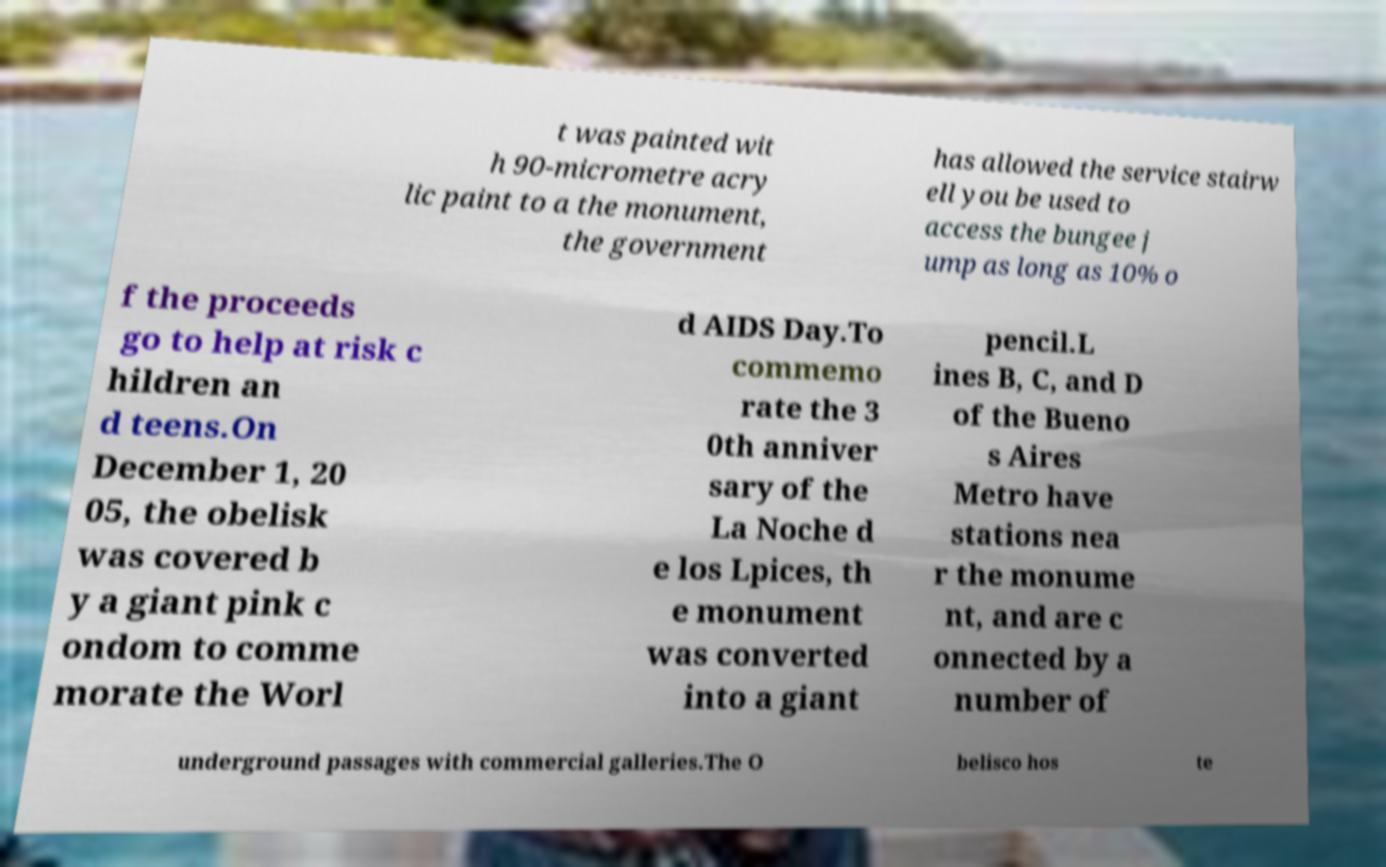Could you assist in decoding the text presented in this image and type it out clearly? t was painted wit h 90-micrometre acry lic paint to a the monument, the government has allowed the service stairw ell you be used to access the bungee j ump as long as 10% o f the proceeds go to help at risk c hildren an d teens.On December 1, 20 05, the obelisk was covered b y a giant pink c ondom to comme morate the Worl d AIDS Day.To commemo rate the 3 0th anniver sary of the La Noche d e los Lpices, th e monument was converted into a giant pencil.L ines B, C, and D of the Bueno s Aires Metro have stations nea r the monume nt, and are c onnected by a number of underground passages with commercial galleries.The O belisco hos te 